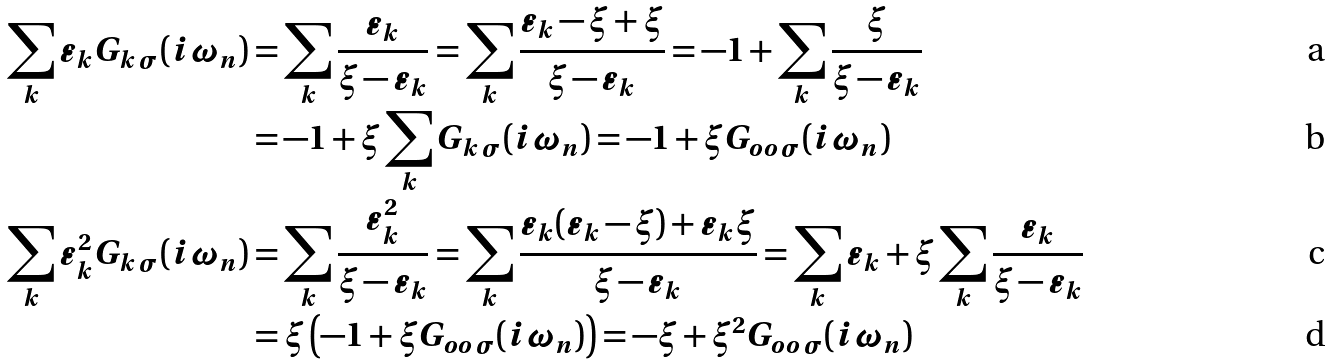<formula> <loc_0><loc_0><loc_500><loc_500>\sum _ { k } \varepsilon _ { k } G _ { k \, \sigma } ( i \omega _ { n } ) & = \sum _ { k } \frac { \varepsilon _ { k } } { \xi - \varepsilon _ { k } } = \sum _ { k } \frac { \varepsilon _ { k } - \xi + \xi } { \xi - \varepsilon _ { k } } = - 1 + \sum _ { k } \frac { \xi } { \xi - \varepsilon _ { k } } \\ & = - 1 + \xi \sum _ { k } G _ { k \, \sigma } ( i \omega _ { n } ) = - 1 + \xi G _ { o o \, \sigma } ( i \omega _ { n } ) \\ \sum _ { k } \varepsilon _ { k } ^ { 2 } G _ { k \, \sigma } ( i \omega _ { n } ) & = \sum _ { k } \frac { \varepsilon _ { k } ^ { 2 } } { \xi - \varepsilon _ { k } } = \sum _ { k } \frac { \varepsilon _ { k } ( \varepsilon _ { k } - \xi ) + \varepsilon _ { k } \xi } { \xi - \varepsilon _ { k } } = \sum _ { k } \varepsilon _ { k } + \xi \sum _ { k } \frac { \varepsilon _ { k } } { \xi - \varepsilon _ { k } } \\ & = \xi \left ( - 1 + \xi G _ { o o \, \sigma } ( i \omega _ { n } ) \right ) = - \xi + \xi ^ { 2 } G _ { o o \, \sigma } ( i \omega _ { n } )</formula> 